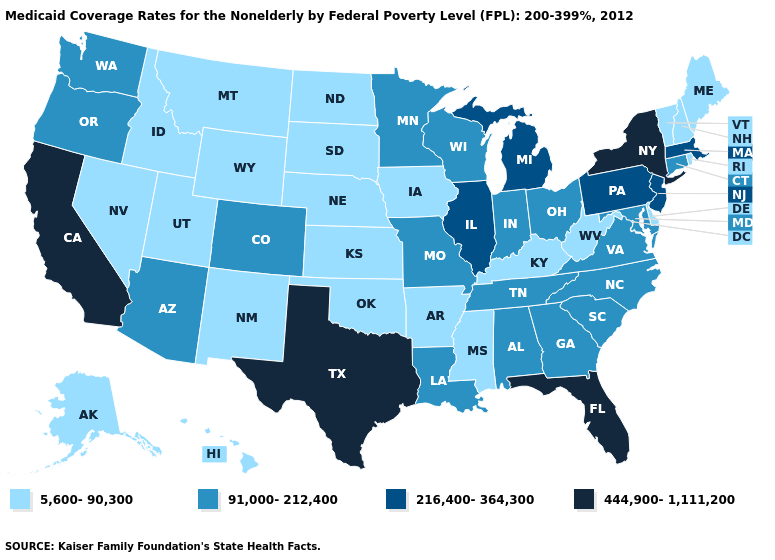What is the value of Maine?
Short answer required. 5,600-90,300. Name the states that have a value in the range 444,900-1,111,200?
Be succinct. California, Florida, New York, Texas. What is the highest value in the South ?
Answer briefly. 444,900-1,111,200. Name the states that have a value in the range 216,400-364,300?
Short answer required. Illinois, Massachusetts, Michigan, New Jersey, Pennsylvania. Which states have the lowest value in the South?
Quick response, please. Arkansas, Delaware, Kentucky, Mississippi, Oklahoma, West Virginia. Which states have the highest value in the USA?
Keep it brief. California, Florida, New York, Texas. Among the states that border Connecticut , which have the highest value?
Short answer required. New York. Name the states that have a value in the range 216,400-364,300?
Concise answer only. Illinois, Massachusetts, Michigan, New Jersey, Pennsylvania. Does South Carolina have the highest value in the USA?
Keep it brief. No. Among the states that border Wisconsin , which have the highest value?
Give a very brief answer. Illinois, Michigan. Does California have the highest value in the West?
Short answer required. Yes. Among the states that border Oklahoma , does Missouri have the highest value?
Be succinct. No. What is the highest value in the South ?
Short answer required. 444,900-1,111,200. Does Vermont have the same value as Oklahoma?
Give a very brief answer. Yes. Name the states that have a value in the range 5,600-90,300?
Answer briefly. Alaska, Arkansas, Delaware, Hawaii, Idaho, Iowa, Kansas, Kentucky, Maine, Mississippi, Montana, Nebraska, Nevada, New Hampshire, New Mexico, North Dakota, Oklahoma, Rhode Island, South Dakota, Utah, Vermont, West Virginia, Wyoming. 